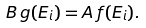Convert formula to latex. <formula><loc_0><loc_0><loc_500><loc_500>B \, g ( E _ { i } ) = A \, f ( E _ { i } ) .</formula> 